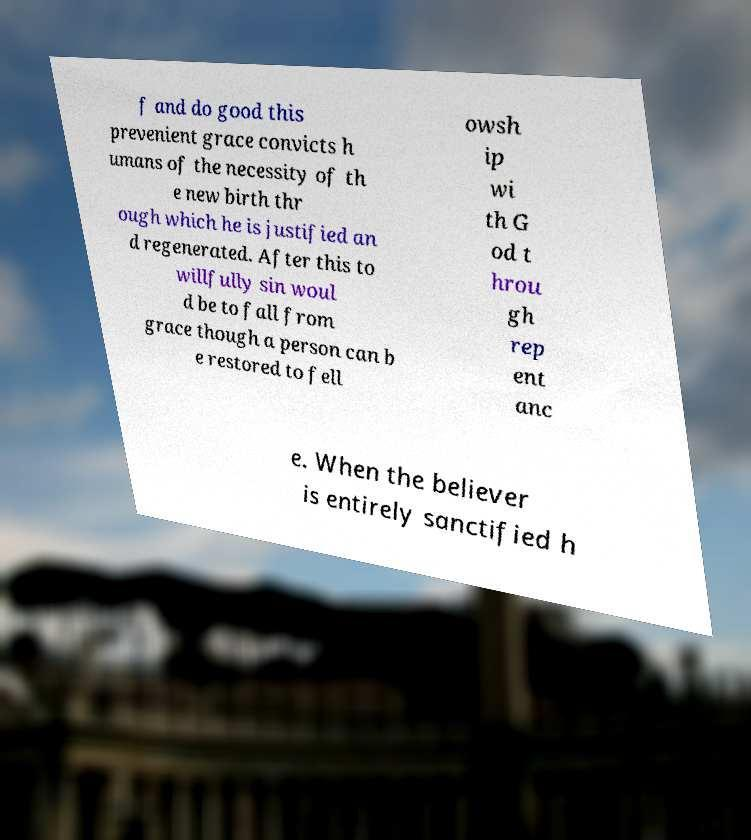There's text embedded in this image that I need extracted. Can you transcribe it verbatim? f and do good this prevenient grace convicts h umans of the necessity of th e new birth thr ough which he is justified an d regenerated. After this to willfully sin woul d be to fall from grace though a person can b e restored to fell owsh ip wi th G od t hrou gh rep ent anc e. When the believer is entirely sanctified h 